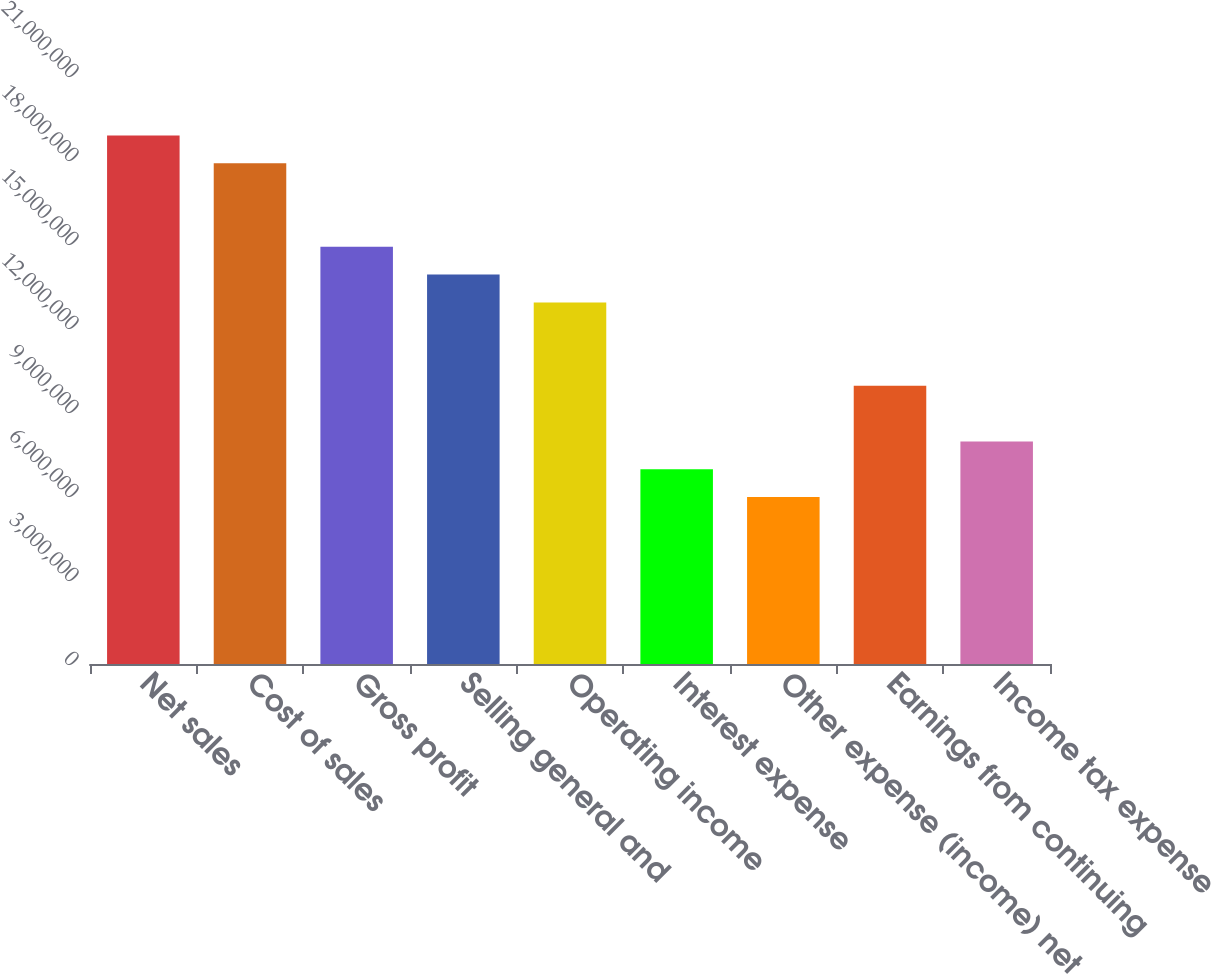Convert chart to OTSL. <chart><loc_0><loc_0><loc_500><loc_500><bar_chart><fcel>Net sales<fcel>Cost of sales<fcel>Gross profit<fcel>Selling general and<fcel>Operating income<fcel>Interest expense<fcel>Other expense (income) net<fcel>Earnings from continuing<fcel>Income tax expense<nl><fcel>1.88754e+07<fcel>1.78819e+07<fcel>1.49016e+07<fcel>1.39082e+07<fcel>1.29147e+07<fcel>6.95408e+06<fcel>5.96064e+06<fcel>9.9344e+06<fcel>7.94752e+06<nl></chart> 